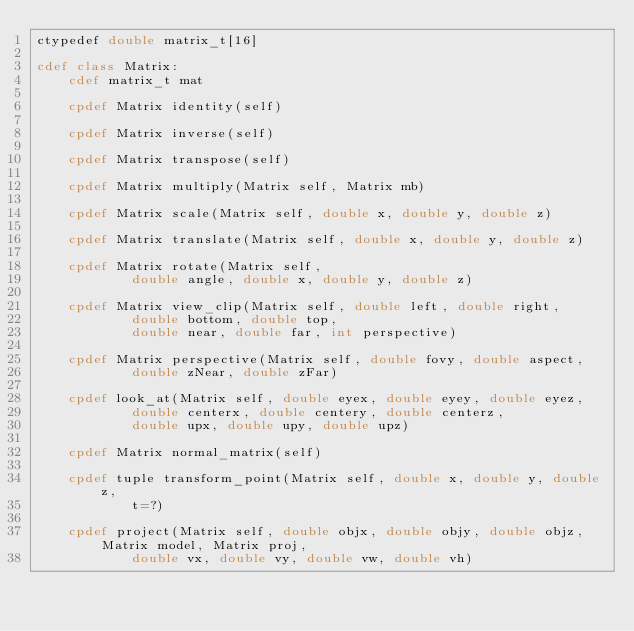<code> <loc_0><loc_0><loc_500><loc_500><_Cython_>ctypedef double matrix_t[16]

cdef class Matrix:
    cdef matrix_t mat

    cpdef Matrix identity(self)

    cpdef Matrix inverse(self)

    cpdef Matrix transpose(self)

    cpdef Matrix multiply(Matrix self, Matrix mb)

    cpdef Matrix scale(Matrix self, double x, double y, double z)

    cpdef Matrix translate(Matrix self, double x, double y, double z)

    cpdef Matrix rotate(Matrix self,
            double angle, double x, double y, double z)

    cpdef Matrix view_clip(Matrix self, double left, double right,
            double bottom, double top,
            double near, double far, int perspective)

    cpdef Matrix perspective(Matrix self, double fovy, double aspect,
            double zNear, double zFar)

    cpdef look_at(Matrix self, double eyex, double eyey, double eyez,
            double centerx, double centery, double centerz,
            double upx, double upy, double upz)

    cpdef Matrix normal_matrix(self)

    cpdef tuple transform_point(Matrix self, double x, double y, double z,
            t=?)

    cpdef project(Matrix self, double objx, double objy, double objz, Matrix model, Matrix proj,
            double vx, double vy, double vw, double vh)
</code> 